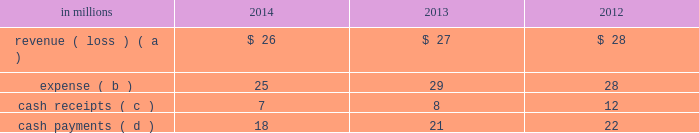The use of the two wholly-owned special purpose entities discussed below preserved the tax deferral that resulted from the 2007 temple-inland timberlands sales .
The company recognized an $ 840 million deferred tax liability in connection with the 2007 sales , which will be settled with the maturity of the notes in in october 2007 , temple-inland sold 1.55 million acres of timberlands for $ 2.38 billion .
The total consideration consisted almost entirely of notes due in 2027 issued by the buyer of the timberlands , which temple-inland contributed to two wholly-owned , bankruptcy-remote special purpose entities .
The notes are shown in financial assets of special purpose entities in the accompanying consolidated balance sheet and are supported by $ 2.38 billion of irrevocable letters of credit issued by three banks , which are required to maintain minimum credit ratings on their long-term debt .
In the third quarter of 2012 , international paper completed its preliminary analysis of the acquisition date fair value of the notes and determined it to be $ 2.09 billion .
As of december 31 , 2014 and 2013 , the fair value of the notes was $ 2.27 billion and $ 2.62 billion , respectively .
These notes are classified as level 2 within the fair value hierarchy , which is further defined in note 14 .
In december 2007 , temple-inland's two wholly-owned special purpose entities borrowed $ 2.14 billion shown in nonrecourse financial liabilities of special purpose entities in the accompanying consolidated balance sheet .
The loans are repayable in 2027 and are secured only by the $ 2.38 billion of notes and the irrevocable letters of credit securing the notes and are nonrecourse to the company .
The loan agreements provide that if a credit rating of any of the banks issuing the letters of credit is downgraded below the specified threshold , the letters of credit issued by that bank must be replaced within 30 days with letters of credit from another qualifying financial institution .
In the third quarter of 2012 , international paper completed its preliminary analysis of the acquisition date fair value of the borrowings and determined it to be $ 2.03 billion .
As of december 31 , 2014 and 2013 , the fair value of this debt was $ 2.16 billion and $ 2.49 billion , respectively .
This debt is classified as level 2 within the fair value hierarchy , which is further defined in note 14 .
During 2012 , the credit ratings for two letter of credit banks that support $ 1.0 billion of the 2007 monetized notes were downgraded below the specified threshold .
These letters of credit were successfully replaced by other qualifying institutions .
Fees of $ 8 million were incurred in connection with these replacements .
Activity between the company and the 2007 financing entities was as follows: .
( a ) the revenue is included in interest expense , net in the accompanying consolidated statement of operations and includes approximately $ 19 million , $ 19 million and $ 17 million for the years ended december 31 , 2014 , 2013 and 2012 , respectively , of accretion income for the amortization of the purchase accounting adjustment of the financial assets of special purpose entities .
( b ) the expense is included in interest expense , net in the accompanying consolidated statement of operations and includes $ 7 million , $ 7 million and $ 6 million for the years ended december 31 , 2014 , 2013 and 2012 , respectively , of accretion expense for the amortization of the purchase accounting adjustment on the nonrecourse financial liabilities of special purpose entities .
( c ) the cash receipts are interest received on the financial assets of special purpose entities .
( d ) the cash payments are interest paid on nonrecourse financial liabilities of special purpose entities .
Preferred securities of subsidiaries in march 2003 , southeast timber , inc .
( southeast timber ) , a consolidated subsidiary of international paper , issued $ 150 million of preferred securities to a private investor with future dividend payments based on libor .
Southeast timber , which through a subsidiary initially held approximately 1.50 million acres of forestlands in the southern united states , was international paper 2019s primary vehicle for sales of southern forestlands .
As of december 31 , 2014 , substantially all of these forestlands have been sold .
On march 27 , 2013 , southeast timber redeemed its class a common shares owned by the private investor for $ 150 million .
Distributions paid to the third-party investor were $ 1 million and $ 6 million in 2013 and 2012 , respectively .
The expense related to these preferred securities is shown in net earnings ( loss ) attributable to noncontrolling interests in the accompanying consolidated statement of operations .
Note 13 debt and lines of credit during the second quarter of 2014 , international paper issued $ 800 million of 3.65% ( 3.65 % ) senior unsecured notes with a maturity date in 2024 and $ 800 million of 4.80% ( 4.80 % ) senior unsecured notes with a maturity date in 2044 .
The proceeds from this borrowing were used to repay approximately $ 960 million of notes with interest rates ranging from 7.95% ( 7.95 % ) to 9.38% ( 9.38 % ) and original maturities from 2018 to 2019 .
Pre-tax early debt retirement costs of $ 262 million related to these debt repayments , including $ 258 million of cash premiums , are included in restructuring and other charges in the .
Based on the review of the activity between the company and the 2007 financing entities what was the ratio of the cash payments to cash receipts in 2012? 
Computations: (22 / 12)
Answer: 1.83333. 